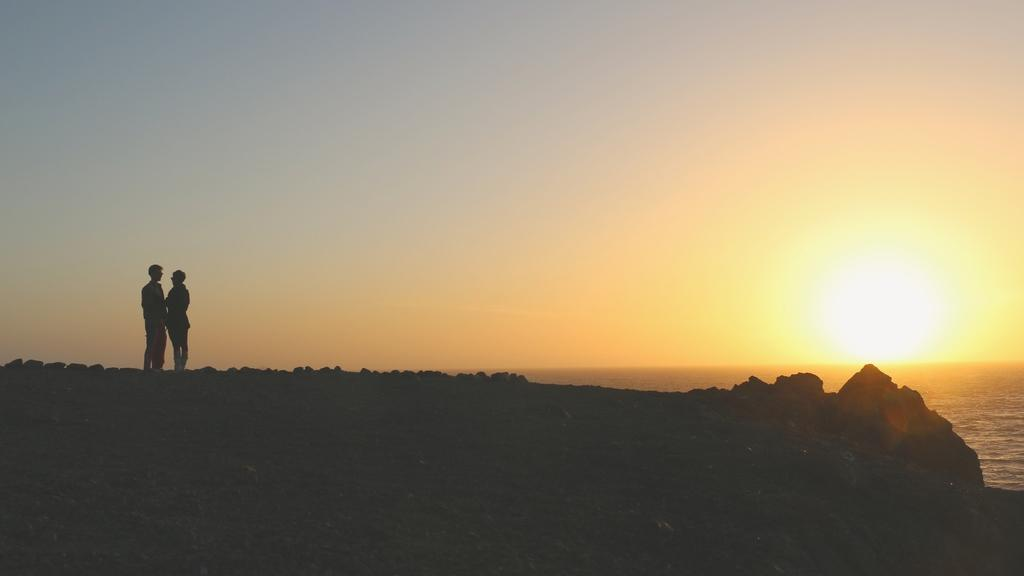How many people are in the image? There are two people in the image. What are the people standing on? The people are standing on rocks. What can be seen in the background of the image? There is sky and an ocean visible in the background of the image. Can the sun be seen in the image? Yes, the sun is observable in the sky. What type of side dish is being served on the rocks in the image? There is no side dish present in the image; the people are standing on rocks near an ocean and sky. What is the purpose of the voyage in the image? There is no voyage depicted in the image; it simply shows two people standing on rocks near an ocean and sky. 